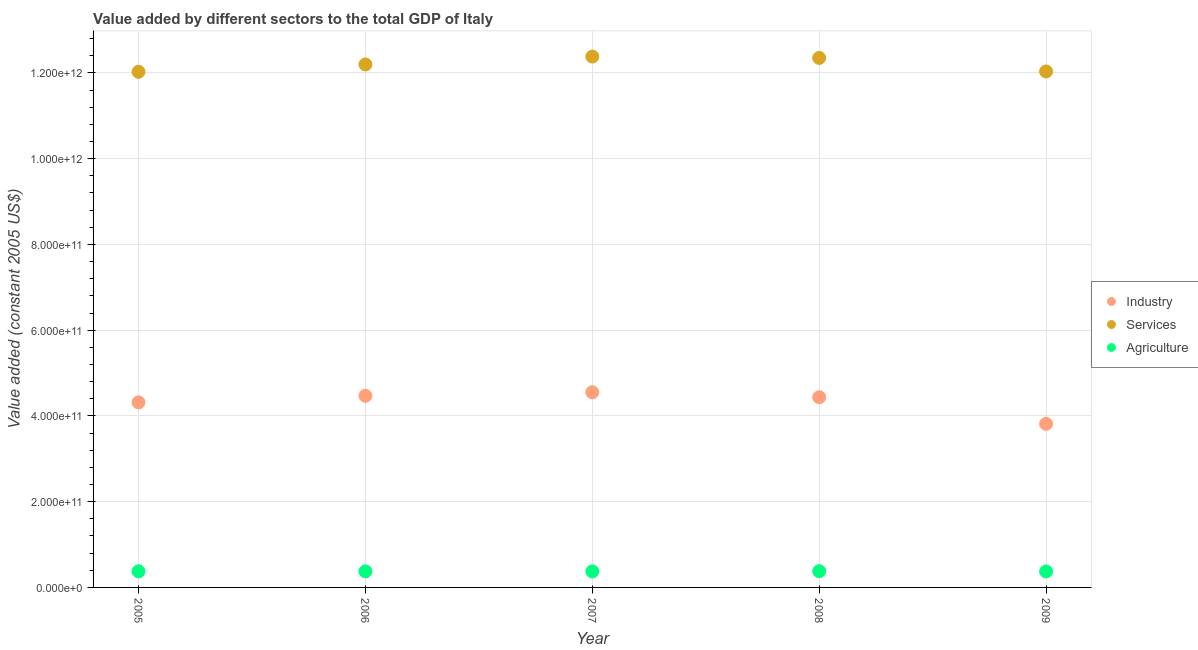What is the value added by industrial sector in 2008?
Your answer should be compact. 4.44e+11. Across all years, what is the maximum value added by industrial sector?
Offer a very short reply. 4.55e+11. Across all years, what is the minimum value added by agricultural sector?
Offer a terse response. 3.72e+1. In which year was the value added by industrial sector maximum?
Your answer should be very brief. 2007. In which year was the value added by services minimum?
Ensure brevity in your answer.  2005. What is the total value added by services in the graph?
Give a very brief answer. 6.10e+12. What is the difference between the value added by agricultural sector in 2007 and that in 2008?
Make the answer very short. -4.34e+08. What is the difference between the value added by industrial sector in 2005 and the value added by agricultural sector in 2008?
Offer a very short reply. 3.94e+11. What is the average value added by agricultural sector per year?
Offer a very short reply. 3.75e+1. In the year 2006, what is the difference between the value added by agricultural sector and value added by services?
Offer a very short reply. -1.18e+12. What is the ratio of the value added by industrial sector in 2006 to that in 2009?
Your response must be concise. 1.17. Is the difference between the value added by services in 2005 and 2009 greater than the difference between the value added by industrial sector in 2005 and 2009?
Your response must be concise. No. What is the difference between the highest and the second highest value added by industrial sector?
Your answer should be compact. 8.29e+09. What is the difference between the highest and the lowest value added by services?
Make the answer very short. 3.55e+1. In how many years, is the value added by industrial sector greater than the average value added by industrial sector taken over all years?
Your answer should be compact. 3. Does the value added by agricultural sector monotonically increase over the years?
Your answer should be compact. No. Is the value added by industrial sector strictly less than the value added by services over the years?
Your response must be concise. Yes. How many dotlines are there?
Your response must be concise. 3. What is the difference between two consecutive major ticks on the Y-axis?
Offer a terse response. 2.00e+11. Where does the legend appear in the graph?
Your answer should be very brief. Center right. How many legend labels are there?
Provide a short and direct response. 3. How are the legend labels stacked?
Your answer should be very brief. Vertical. What is the title of the graph?
Ensure brevity in your answer.  Value added by different sectors to the total GDP of Italy. What is the label or title of the X-axis?
Ensure brevity in your answer.  Year. What is the label or title of the Y-axis?
Offer a very short reply. Value added (constant 2005 US$). What is the Value added (constant 2005 US$) in Industry in 2005?
Your response must be concise. 4.32e+11. What is the Value added (constant 2005 US$) in Services in 2005?
Your answer should be compact. 1.20e+12. What is the Value added (constant 2005 US$) in Agriculture in 2005?
Give a very brief answer. 3.76e+1. What is the Value added (constant 2005 US$) in Industry in 2006?
Make the answer very short. 4.47e+11. What is the Value added (constant 2005 US$) of Services in 2006?
Give a very brief answer. 1.22e+12. What is the Value added (constant 2005 US$) in Agriculture in 2006?
Ensure brevity in your answer.  3.74e+1. What is the Value added (constant 2005 US$) of Industry in 2007?
Offer a terse response. 4.55e+11. What is the Value added (constant 2005 US$) of Services in 2007?
Your response must be concise. 1.24e+12. What is the Value added (constant 2005 US$) in Agriculture in 2007?
Your answer should be compact. 3.74e+1. What is the Value added (constant 2005 US$) in Industry in 2008?
Your answer should be very brief. 4.44e+11. What is the Value added (constant 2005 US$) in Services in 2008?
Offer a terse response. 1.24e+12. What is the Value added (constant 2005 US$) of Agriculture in 2008?
Your answer should be very brief. 3.79e+1. What is the Value added (constant 2005 US$) in Industry in 2009?
Your answer should be compact. 3.82e+11. What is the Value added (constant 2005 US$) of Services in 2009?
Offer a terse response. 1.20e+12. What is the Value added (constant 2005 US$) of Agriculture in 2009?
Provide a short and direct response. 3.72e+1. Across all years, what is the maximum Value added (constant 2005 US$) of Industry?
Ensure brevity in your answer.  4.55e+11. Across all years, what is the maximum Value added (constant 2005 US$) of Services?
Your answer should be compact. 1.24e+12. Across all years, what is the maximum Value added (constant 2005 US$) in Agriculture?
Offer a very short reply. 3.79e+1. Across all years, what is the minimum Value added (constant 2005 US$) of Industry?
Your response must be concise. 3.82e+11. Across all years, what is the minimum Value added (constant 2005 US$) of Services?
Provide a succinct answer. 1.20e+12. Across all years, what is the minimum Value added (constant 2005 US$) of Agriculture?
Provide a succinct answer. 3.72e+1. What is the total Value added (constant 2005 US$) in Industry in the graph?
Your answer should be compact. 2.16e+12. What is the total Value added (constant 2005 US$) in Services in the graph?
Your answer should be very brief. 6.10e+12. What is the total Value added (constant 2005 US$) in Agriculture in the graph?
Give a very brief answer. 1.88e+11. What is the difference between the Value added (constant 2005 US$) in Industry in 2005 and that in 2006?
Your answer should be compact. -1.53e+1. What is the difference between the Value added (constant 2005 US$) in Services in 2005 and that in 2006?
Your answer should be very brief. -1.72e+1. What is the difference between the Value added (constant 2005 US$) of Agriculture in 2005 and that in 2006?
Provide a short and direct response. 2.22e+08. What is the difference between the Value added (constant 2005 US$) in Industry in 2005 and that in 2007?
Ensure brevity in your answer.  -2.36e+1. What is the difference between the Value added (constant 2005 US$) in Services in 2005 and that in 2007?
Your answer should be very brief. -3.55e+1. What is the difference between the Value added (constant 2005 US$) in Agriculture in 2005 and that in 2007?
Give a very brief answer. 1.60e+08. What is the difference between the Value added (constant 2005 US$) of Industry in 2005 and that in 2008?
Provide a succinct answer. -1.20e+1. What is the difference between the Value added (constant 2005 US$) in Services in 2005 and that in 2008?
Provide a short and direct response. -3.24e+1. What is the difference between the Value added (constant 2005 US$) of Agriculture in 2005 and that in 2008?
Keep it short and to the point. -2.73e+08. What is the difference between the Value added (constant 2005 US$) of Industry in 2005 and that in 2009?
Your answer should be compact. 5.00e+1. What is the difference between the Value added (constant 2005 US$) in Services in 2005 and that in 2009?
Give a very brief answer. -7.75e+08. What is the difference between the Value added (constant 2005 US$) of Agriculture in 2005 and that in 2009?
Provide a short and direct response. 3.42e+08. What is the difference between the Value added (constant 2005 US$) of Industry in 2006 and that in 2007?
Your answer should be compact. -8.29e+09. What is the difference between the Value added (constant 2005 US$) of Services in 2006 and that in 2007?
Provide a succinct answer. -1.84e+1. What is the difference between the Value added (constant 2005 US$) in Agriculture in 2006 and that in 2007?
Keep it short and to the point. -6.16e+07. What is the difference between the Value added (constant 2005 US$) in Industry in 2006 and that in 2008?
Your response must be concise. 3.36e+09. What is the difference between the Value added (constant 2005 US$) in Services in 2006 and that in 2008?
Make the answer very short. -1.52e+1. What is the difference between the Value added (constant 2005 US$) in Agriculture in 2006 and that in 2008?
Provide a short and direct response. -4.95e+08. What is the difference between the Value added (constant 2005 US$) in Industry in 2006 and that in 2009?
Provide a short and direct response. 6.54e+1. What is the difference between the Value added (constant 2005 US$) in Services in 2006 and that in 2009?
Offer a very short reply. 1.64e+1. What is the difference between the Value added (constant 2005 US$) of Agriculture in 2006 and that in 2009?
Give a very brief answer. 1.21e+08. What is the difference between the Value added (constant 2005 US$) in Industry in 2007 and that in 2008?
Provide a short and direct response. 1.17e+1. What is the difference between the Value added (constant 2005 US$) of Services in 2007 and that in 2008?
Your response must be concise. 3.16e+09. What is the difference between the Value added (constant 2005 US$) in Agriculture in 2007 and that in 2008?
Your answer should be compact. -4.34e+08. What is the difference between the Value added (constant 2005 US$) in Industry in 2007 and that in 2009?
Provide a succinct answer. 7.36e+1. What is the difference between the Value added (constant 2005 US$) of Services in 2007 and that in 2009?
Provide a succinct answer. 3.48e+1. What is the difference between the Value added (constant 2005 US$) in Agriculture in 2007 and that in 2009?
Provide a short and direct response. 1.82e+08. What is the difference between the Value added (constant 2005 US$) of Industry in 2008 and that in 2009?
Provide a succinct answer. 6.20e+1. What is the difference between the Value added (constant 2005 US$) in Services in 2008 and that in 2009?
Your response must be concise. 3.16e+1. What is the difference between the Value added (constant 2005 US$) in Agriculture in 2008 and that in 2009?
Provide a succinct answer. 6.16e+08. What is the difference between the Value added (constant 2005 US$) in Industry in 2005 and the Value added (constant 2005 US$) in Services in 2006?
Give a very brief answer. -7.88e+11. What is the difference between the Value added (constant 2005 US$) in Industry in 2005 and the Value added (constant 2005 US$) in Agriculture in 2006?
Provide a short and direct response. 3.94e+11. What is the difference between the Value added (constant 2005 US$) of Services in 2005 and the Value added (constant 2005 US$) of Agriculture in 2006?
Offer a very short reply. 1.17e+12. What is the difference between the Value added (constant 2005 US$) in Industry in 2005 and the Value added (constant 2005 US$) in Services in 2007?
Your response must be concise. -8.07e+11. What is the difference between the Value added (constant 2005 US$) in Industry in 2005 and the Value added (constant 2005 US$) in Agriculture in 2007?
Ensure brevity in your answer.  3.94e+11. What is the difference between the Value added (constant 2005 US$) in Services in 2005 and the Value added (constant 2005 US$) in Agriculture in 2007?
Give a very brief answer. 1.17e+12. What is the difference between the Value added (constant 2005 US$) of Industry in 2005 and the Value added (constant 2005 US$) of Services in 2008?
Ensure brevity in your answer.  -8.03e+11. What is the difference between the Value added (constant 2005 US$) in Industry in 2005 and the Value added (constant 2005 US$) in Agriculture in 2008?
Keep it short and to the point. 3.94e+11. What is the difference between the Value added (constant 2005 US$) of Services in 2005 and the Value added (constant 2005 US$) of Agriculture in 2008?
Give a very brief answer. 1.16e+12. What is the difference between the Value added (constant 2005 US$) of Industry in 2005 and the Value added (constant 2005 US$) of Services in 2009?
Offer a terse response. -7.72e+11. What is the difference between the Value added (constant 2005 US$) of Industry in 2005 and the Value added (constant 2005 US$) of Agriculture in 2009?
Make the answer very short. 3.94e+11. What is the difference between the Value added (constant 2005 US$) of Services in 2005 and the Value added (constant 2005 US$) of Agriculture in 2009?
Give a very brief answer. 1.17e+12. What is the difference between the Value added (constant 2005 US$) of Industry in 2006 and the Value added (constant 2005 US$) of Services in 2007?
Give a very brief answer. -7.91e+11. What is the difference between the Value added (constant 2005 US$) of Industry in 2006 and the Value added (constant 2005 US$) of Agriculture in 2007?
Keep it short and to the point. 4.09e+11. What is the difference between the Value added (constant 2005 US$) in Services in 2006 and the Value added (constant 2005 US$) in Agriculture in 2007?
Offer a very short reply. 1.18e+12. What is the difference between the Value added (constant 2005 US$) of Industry in 2006 and the Value added (constant 2005 US$) of Services in 2008?
Your response must be concise. -7.88e+11. What is the difference between the Value added (constant 2005 US$) of Industry in 2006 and the Value added (constant 2005 US$) of Agriculture in 2008?
Make the answer very short. 4.09e+11. What is the difference between the Value added (constant 2005 US$) in Services in 2006 and the Value added (constant 2005 US$) in Agriculture in 2008?
Provide a succinct answer. 1.18e+12. What is the difference between the Value added (constant 2005 US$) in Industry in 2006 and the Value added (constant 2005 US$) in Services in 2009?
Give a very brief answer. -7.56e+11. What is the difference between the Value added (constant 2005 US$) in Industry in 2006 and the Value added (constant 2005 US$) in Agriculture in 2009?
Offer a very short reply. 4.10e+11. What is the difference between the Value added (constant 2005 US$) in Services in 2006 and the Value added (constant 2005 US$) in Agriculture in 2009?
Make the answer very short. 1.18e+12. What is the difference between the Value added (constant 2005 US$) in Industry in 2007 and the Value added (constant 2005 US$) in Services in 2008?
Your answer should be very brief. -7.80e+11. What is the difference between the Value added (constant 2005 US$) of Industry in 2007 and the Value added (constant 2005 US$) of Agriculture in 2008?
Offer a very short reply. 4.17e+11. What is the difference between the Value added (constant 2005 US$) of Services in 2007 and the Value added (constant 2005 US$) of Agriculture in 2008?
Your answer should be compact. 1.20e+12. What is the difference between the Value added (constant 2005 US$) in Industry in 2007 and the Value added (constant 2005 US$) in Services in 2009?
Give a very brief answer. -7.48e+11. What is the difference between the Value added (constant 2005 US$) of Industry in 2007 and the Value added (constant 2005 US$) of Agriculture in 2009?
Provide a succinct answer. 4.18e+11. What is the difference between the Value added (constant 2005 US$) of Services in 2007 and the Value added (constant 2005 US$) of Agriculture in 2009?
Your response must be concise. 1.20e+12. What is the difference between the Value added (constant 2005 US$) in Industry in 2008 and the Value added (constant 2005 US$) in Services in 2009?
Your answer should be compact. -7.60e+11. What is the difference between the Value added (constant 2005 US$) of Industry in 2008 and the Value added (constant 2005 US$) of Agriculture in 2009?
Your answer should be compact. 4.06e+11. What is the difference between the Value added (constant 2005 US$) in Services in 2008 and the Value added (constant 2005 US$) in Agriculture in 2009?
Keep it short and to the point. 1.20e+12. What is the average Value added (constant 2005 US$) in Industry per year?
Your answer should be compact. 4.32e+11. What is the average Value added (constant 2005 US$) of Services per year?
Provide a succinct answer. 1.22e+12. What is the average Value added (constant 2005 US$) of Agriculture per year?
Give a very brief answer. 3.75e+1. In the year 2005, what is the difference between the Value added (constant 2005 US$) of Industry and Value added (constant 2005 US$) of Services?
Provide a succinct answer. -7.71e+11. In the year 2005, what is the difference between the Value added (constant 2005 US$) in Industry and Value added (constant 2005 US$) in Agriculture?
Your answer should be compact. 3.94e+11. In the year 2005, what is the difference between the Value added (constant 2005 US$) in Services and Value added (constant 2005 US$) in Agriculture?
Offer a terse response. 1.17e+12. In the year 2006, what is the difference between the Value added (constant 2005 US$) of Industry and Value added (constant 2005 US$) of Services?
Keep it short and to the point. -7.73e+11. In the year 2006, what is the difference between the Value added (constant 2005 US$) in Industry and Value added (constant 2005 US$) in Agriculture?
Ensure brevity in your answer.  4.10e+11. In the year 2006, what is the difference between the Value added (constant 2005 US$) in Services and Value added (constant 2005 US$) in Agriculture?
Keep it short and to the point. 1.18e+12. In the year 2007, what is the difference between the Value added (constant 2005 US$) of Industry and Value added (constant 2005 US$) of Services?
Provide a succinct answer. -7.83e+11. In the year 2007, what is the difference between the Value added (constant 2005 US$) in Industry and Value added (constant 2005 US$) in Agriculture?
Ensure brevity in your answer.  4.18e+11. In the year 2007, what is the difference between the Value added (constant 2005 US$) of Services and Value added (constant 2005 US$) of Agriculture?
Give a very brief answer. 1.20e+12. In the year 2008, what is the difference between the Value added (constant 2005 US$) in Industry and Value added (constant 2005 US$) in Services?
Your answer should be compact. -7.91e+11. In the year 2008, what is the difference between the Value added (constant 2005 US$) in Industry and Value added (constant 2005 US$) in Agriculture?
Your answer should be compact. 4.06e+11. In the year 2008, what is the difference between the Value added (constant 2005 US$) in Services and Value added (constant 2005 US$) in Agriculture?
Your answer should be very brief. 1.20e+12. In the year 2009, what is the difference between the Value added (constant 2005 US$) in Industry and Value added (constant 2005 US$) in Services?
Your answer should be compact. -8.22e+11. In the year 2009, what is the difference between the Value added (constant 2005 US$) in Industry and Value added (constant 2005 US$) in Agriculture?
Give a very brief answer. 3.44e+11. In the year 2009, what is the difference between the Value added (constant 2005 US$) of Services and Value added (constant 2005 US$) of Agriculture?
Give a very brief answer. 1.17e+12. What is the ratio of the Value added (constant 2005 US$) of Industry in 2005 to that in 2006?
Give a very brief answer. 0.97. What is the ratio of the Value added (constant 2005 US$) in Services in 2005 to that in 2006?
Ensure brevity in your answer.  0.99. What is the ratio of the Value added (constant 2005 US$) in Agriculture in 2005 to that in 2006?
Provide a succinct answer. 1.01. What is the ratio of the Value added (constant 2005 US$) of Industry in 2005 to that in 2007?
Your answer should be very brief. 0.95. What is the ratio of the Value added (constant 2005 US$) of Services in 2005 to that in 2007?
Keep it short and to the point. 0.97. What is the ratio of the Value added (constant 2005 US$) of Services in 2005 to that in 2008?
Offer a terse response. 0.97. What is the ratio of the Value added (constant 2005 US$) in Agriculture in 2005 to that in 2008?
Your answer should be compact. 0.99. What is the ratio of the Value added (constant 2005 US$) in Industry in 2005 to that in 2009?
Ensure brevity in your answer.  1.13. What is the ratio of the Value added (constant 2005 US$) in Agriculture in 2005 to that in 2009?
Keep it short and to the point. 1.01. What is the ratio of the Value added (constant 2005 US$) of Industry in 2006 to that in 2007?
Your answer should be very brief. 0.98. What is the ratio of the Value added (constant 2005 US$) of Services in 2006 to that in 2007?
Ensure brevity in your answer.  0.99. What is the ratio of the Value added (constant 2005 US$) of Industry in 2006 to that in 2008?
Your answer should be compact. 1.01. What is the ratio of the Value added (constant 2005 US$) of Agriculture in 2006 to that in 2008?
Keep it short and to the point. 0.99. What is the ratio of the Value added (constant 2005 US$) of Industry in 2006 to that in 2009?
Provide a short and direct response. 1.17. What is the ratio of the Value added (constant 2005 US$) of Services in 2006 to that in 2009?
Your answer should be compact. 1.01. What is the ratio of the Value added (constant 2005 US$) in Agriculture in 2006 to that in 2009?
Ensure brevity in your answer.  1. What is the ratio of the Value added (constant 2005 US$) of Industry in 2007 to that in 2008?
Offer a terse response. 1.03. What is the ratio of the Value added (constant 2005 US$) in Services in 2007 to that in 2008?
Keep it short and to the point. 1. What is the ratio of the Value added (constant 2005 US$) of Agriculture in 2007 to that in 2008?
Keep it short and to the point. 0.99. What is the ratio of the Value added (constant 2005 US$) in Industry in 2007 to that in 2009?
Offer a terse response. 1.19. What is the ratio of the Value added (constant 2005 US$) in Services in 2007 to that in 2009?
Offer a terse response. 1.03. What is the ratio of the Value added (constant 2005 US$) in Industry in 2008 to that in 2009?
Your answer should be very brief. 1.16. What is the ratio of the Value added (constant 2005 US$) in Services in 2008 to that in 2009?
Provide a short and direct response. 1.03. What is the ratio of the Value added (constant 2005 US$) of Agriculture in 2008 to that in 2009?
Provide a succinct answer. 1.02. What is the difference between the highest and the second highest Value added (constant 2005 US$) of Industry?
Your answer should be compact. 8.29e+09. What is the difference between the highest and the second highest Value added (constant 2005 US$) of Services?
Make the answer very short. 3.16e+09. What is the difference between the highest and the second highest Value added (constant 2005 US$) in Agriculture?
Offer a terse response. 2.73e+08. What is the difference between the highest and the lowest Value added (constant 2005 US$) in Industry?
Give a very brief answer. 7.36e+1. What is the difference between the highest and the lowest Value added (constant 2005 US$) of Services?
Provide a succinct answer. 3.55e+1. What is the difference between the highest and the lowest Value added (constant 2005 US$) of Agriculture?
Provide a short and direct response. 6.16e+08. 